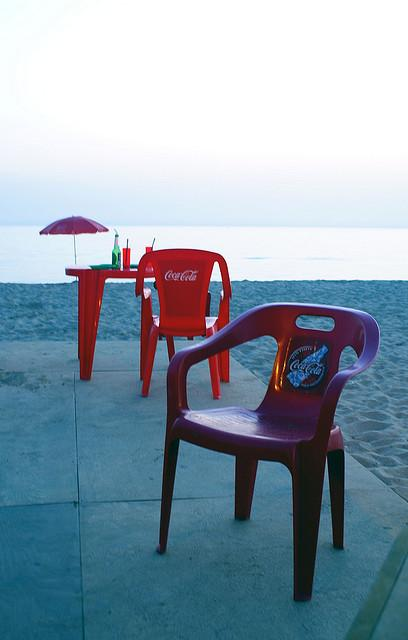What drink brand is seen on the chairs? coca cola 